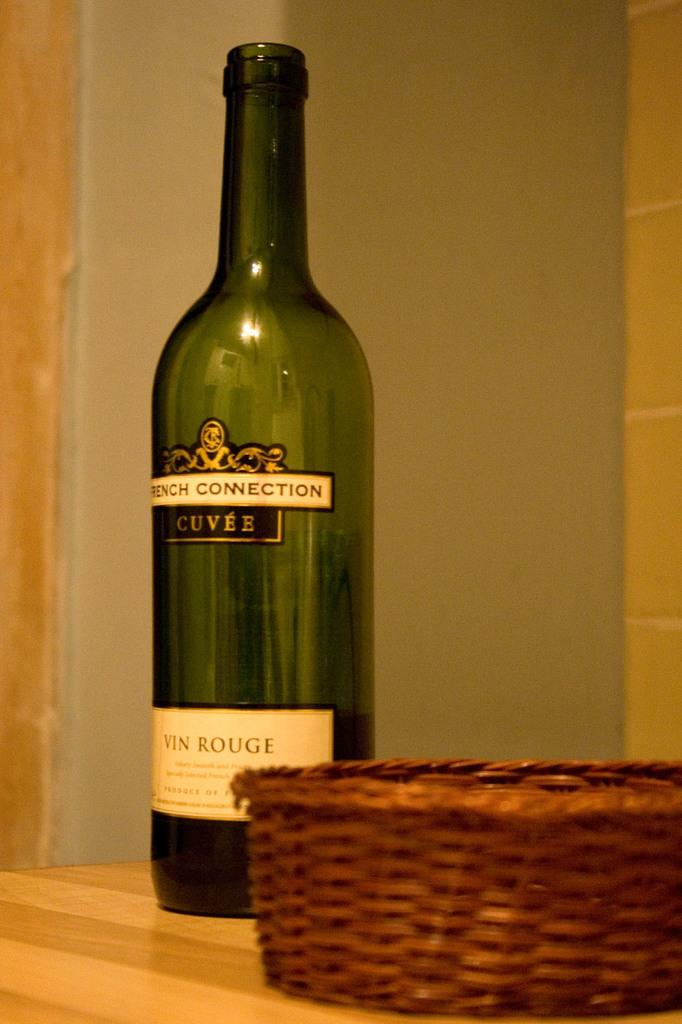<image>
Offer a succinct explanation of the picture presented. A bottle of wine which has the words Vin rouge on the bottom. 